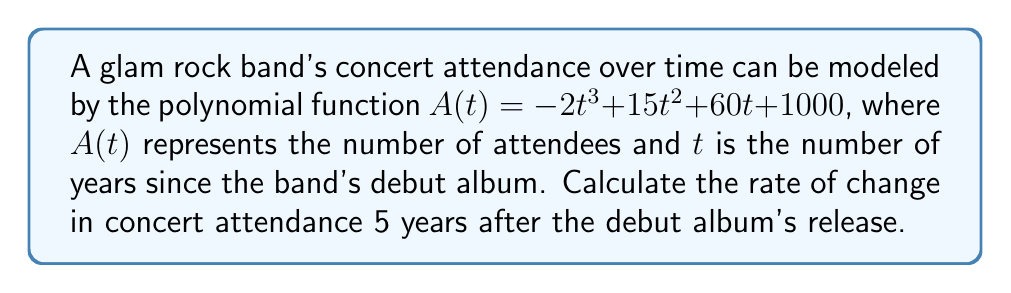Could you help me with this problem? To solve this problem, we need to follow these steps:

1) The rate of change in attendance is given by the derivative of the attendance function $A(t)$.

2) Let's find the derivative $A'(t)$:
   $$A'(t) = \frac{d}{dt}(-2t^3 + 15t^2 + 60t + 1000)$$
   $$A'(t) = -6t^2 + 30t + 60$$

3) We're asked to find the rate of change 5 years after the debut, so we need to evaluate $A'(5)$:
   $$A'(5) = -6(5)^2 + 30(5) + 60$$
   $$= -6(25) + 150 + 60$$
   $$= -150 + 150 + 60$$
   $$= 60$$

4) The units for this rate of change would be attendees per year, as we're measuring the change in number of attendees over time.
Answer: The rate of change in concert attendance 5 years after the debut album's release is 60 attendees per year. 